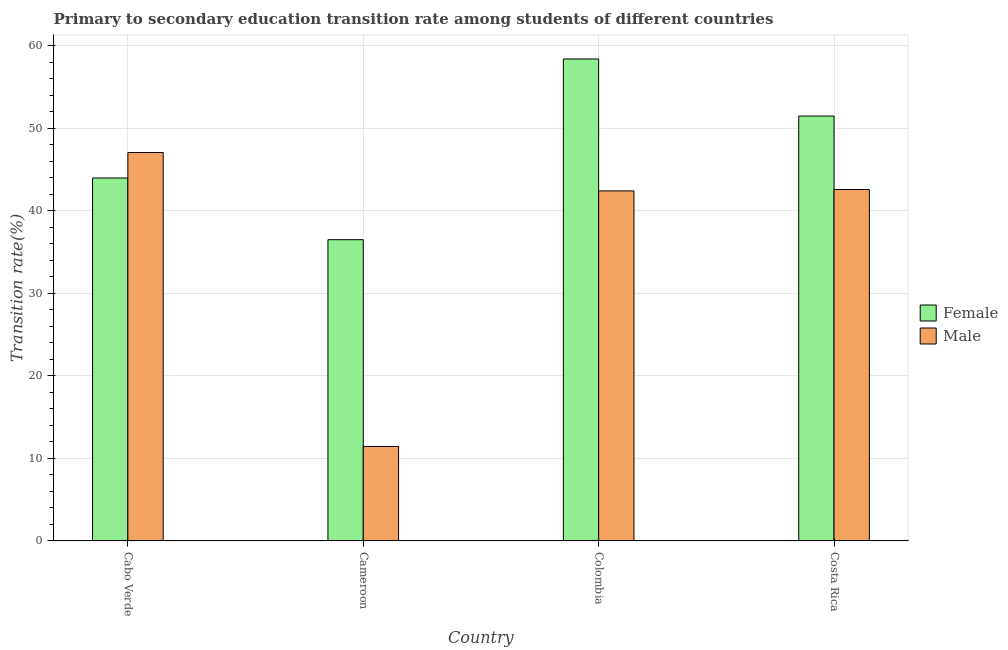How many groups of bars are there?
Provide a succinct answer. 4. Are the number of bars per tick equal to the number of legend labels?
Offer a terse response. Yes. Are the number of bars on each tick of the X-axis equal?
Your answer should be compact. Yes. How many bars are there on the 2nd tick from the left?
Your answer should be compact. 2. What is the label of the 1st group of bars from the left?
Make the answer very short. Cabo Verde. What is the transition rate among male students in Costa Rica?
Provide a succinct answer. 42.57. Across all countries, what is the maximum transition rate among male students?
Offer a terse response. 47.05. Across all countries, what is the minimum transition rate among female students?
Make the answer very short. 36.49. In which country was the transition rate among male students maximum?
Provide a succinct answer. Cabo Verde. In which country was the transition rate among female students minimum?
Keep it short and to the point. Cameroon. What is the total transition rate among male students in the graph?
Offer a very short reply. 143.48. What is the difference between the transition rate among female students in Cameroon and that in Colombia?
Keep it short and to the point. -21.89. What is the difference between the transition rate among male students in Costa Rica and the transition rate among female students in Cabo Verde?
Make the answer very short. -1.39. What is the average transition rate among male students per country?
Provide a succinct answer. 35.87. What is the difference between the transition rate among male students and transition rate among female students in Colombia?
Offer a terse response. -15.98. In how many countries, is the transition rate among male students greater than 44 %?
Make the answer very short. 1. What is the ratio of the transition rate among female students in Cameroon to that in Costa Rica?
Offer a very short reply. 0.71. Is the difference between the transition rate among male students in Cameroon and Costa Rica greater than the difference between the transition rate among female students in Cameroon and Costa Rica?
Keep it short and to the point. No. What is the difference between the highest and the second highest transition rate among female students?
Your answer should be compact. 6.91. What is the difference between the highest and the lowest transition rate among female students?
Offer a terse response. 21.89. Is the sum of the transition rate among female students in Colombia and Costa Rica greater than the maximum transition rate among male students across all countries?
Give a very brief answer. Yes. What does the 2nd bar from the left in Colombia represents?
Your answer should be compact. Male. How many bars are there?
Provide a succinct answer. 8. How many countries are there in the graph?
Ensure brevity in your answer.  4. What is the difference between two consecutive major ticks on the Y-axis?
Your response must be concise. 10. Does the graph contain any zero values?
Your answer should be very brief. No. How many legend labels are there?
Offer a terse response. 2. What is the title of the graph?
Provide a succinct answer. Primary to secondary education transition rate among students of different countries. What is the label or title of the Y-axis?
Offer a terse response. Transition rate(%). What is the Transition rate(%) of Female in Cabo Verde?
Keep it short and to the point. 43.97. What is the Transition rate(%) of Male in Cabo Verde?
Your response must be concise. 47.05. What is the Transition rate(%) of Female in Cameroon?
Give a very brief answer. 36.49. What is the Transition rate(%) in Male in Cameroon?
Ensure brevity in your answer.  11.45. What is the Transition rate(%) of Female in Colombia?
Offer a very short reply. 58.38. What is the Transition rate(%) in Male in Colombia?
Your answer should be very brief. 42.4. What is the Transition rate(%) in Female in Costa Rica?
Ensure brevity in your answer.  51.47. What is the Transition rate(%) in Male in Costa Rica?
Your answer should be compact. 42.57. Across all countries, what is the maximum Transition rate(%) of Female?
Your response must be concise. 58.38. Across all countries, what is the maximum Transition rate(%) of Male?
Your answer should be compact. 47.05. Across all countries, what is the minimum Transition rate(%) of Female?
Keep it short and to the point. 36.49. Across all countries, what is the minimum Transition rate(%) in Male?
Offer a very short reply. 11.45. What is the total Transition rate(%) of Female in the graph?
Provide a succinct answer. 190.32. What is the total Transition rate(%) in Male in the graph?
Give a very brief answer. 143.48. What is the difference between the Transition rate(%) in Female in Cabo Verde and that in Cameroon?
Offer a very short reply. 7.47. What is the difference between the Transition rate(%) in Male in Cabo Verde and that in Cameroon?
Offer a terse response. 35.61. What is the difference between the Transition rate(%) in Female in Cabo Verde and that in Colombia?
Provide a short and direct response. -14.42. What is the difference between the Transition rate(%) of Male in Cabo Verde and that in Colombia?
Provide a short and direct response. 4.65. What is the difference between the Transition rate(%) of Female in Cabo Verde and that in Costa Rica?
Offer a very short reply. -7.5. What is the difference between the Transition rate(%) of Male in Cabo Verde and that in Costa Rica?
Ensure brevity in your answer.  4.48. What is the difference between the Transition rate(%) of Female in Cameroon and that in Colombia?
Your answer should be compact. -21.89. What is the difference between the Transition rate(%) in Male in Cameroon and that in Colombia?
Provide a succinct answer. -30.96. What is the difference between the Transition rate(%) in Female in Cameroon and that in Costa Rica?
Provide a short and direct response. -14.98. What is the difference between the Transition rate(%) of Male in Cameroon and that in Costa Rica?
Your answer should be compact. -31.13. What is the difference between the Transition rate(%) of Female in Colombia and that in Costa Rica?
Provide a short and direct response. 6.91. What is the difference between the Transition rate(%) of Male in Colombia and that in Costa Rica?
Your answer should be compact. -0.17. What is the difference between the Transition rate(%) of Female in Cabo Verde and the Transition rate(%) of Male in Cameroon?
Your answer should be very brief. 32.52. What is the difference between the Transition rate(%) of Female in Cabo Verde and the Transition rate(%) of Male in Colombia?
Give a very brief answer. 1.56. What is the difference between the Transition rate(%) in Female in Cabo Verde and the Transition rate(%) in Male in Costa Rica?
Offer a terse response. 1.39. What is the difference between the Transition rate(%) in Female in Cameroon and the Transition rate(%) in Male in Colombia?
Your answer should be very brief. -5.91. What is the difference between the Transition rate(%) in Female in Cameroon and the Transition rate(%) in Male in Costa Rica?
Ensure brevity in your answer.  -6.08. What is the difference between the Transition rate(%) in Female in Colombia and the Transition rate(%) in Male in Costa Rica?
Make the answer very short. 15.81. What is the average Transition rate(%) in Female per country?
Your answer should be very brief. 47.58. What is the average Transition rate(%) of Male per country?
Your response must be concise. 35.87. What is the difference between the Transition rate(%) of Female and Transition rate(%) of Male in Cabo Verde?
Make the answer very short. -3.08. What is the difference between the Transition rate(%) of Female and Transition rate(%) of Male in Cameroon?
Give a very brief answer. 25.05. What is the difference between the Transition rate(%) in Female and Transition rate(%) in Male in Colombia?
Your answer should be compact. 15.98. What is the difference between the Transition rate(%) in Female and Transition rate(%) in Male in Costa Rica?
Keep it short and to the point. 8.9. What is the ratio of the Transition rate(%) of Female in Cabo Verde to that in Cameroon?
Ensure brevity in your answer.  1.2. What is the ratio of the Transition rate(%) in Male in Cabo Verde to that in Cameroon?
Your answer should be compact. 4.11. What is the ratio of the Transition rate(%) of Female in Cabo Verde to that in Colombia?
Give a very brief answer. 0.75. What is the ratio of the Transition rate(%) in Male in Cabo Verde to that in Colombia?
Provide a succinct answer. 1.11. What is the ratio of the Transition rate(%) in Female in Cabo Verde to that in Costa Rica?
Your answer should be very brief. 0.85. What is the ratio of the Transition rate(%) of Male in Cabo Verde to that in Costa Rica?
Offer a terse response. 1.11. What is the ratio of the Transition rate(%) of Male in Cameroon to that in Colombia?
Your answer should be compact. 0.27. What is the ratio of the Transition rate(%) of Female in Cameroon to that in Costa Rica?
Your response must be concise. 0.71. What is the ratio of the Transition rate(%) in Male in Cameroon to that in Costa Rica?
Your response must be concise. 0.27. What is the ratio of the Transition rate(%) of Female in Colombia to that in Costa Rica?
Offer a very short reply. 1.13. What is the ratio of the Transition rate(%) in Male in Colombia to that in Costa Rica?
Provide a succinct answer. 1. What is the difference between the highest and the second highest Transition rate(%) of Female?
Offer a very short reply. 6.91. What is the difference between the highest and the second highest Transition rate(%) of Male?
Offer a very short reply. 4.48. What is the difference between the highest and the lowest Transition rate(%) of Female?
Your answer should be very brief. 21.89. What is the difference between the highest and the lowest Transition rate(%) in Male?
Your answer should be compact. 35.61. 